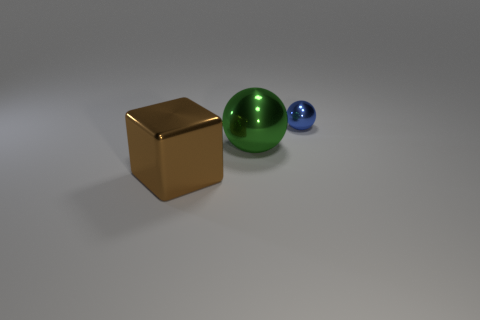Is there anything else that is the same size as the blue sphere?
Your response must be concise. No. There is a object that is behind the large green sphere; is it the same size as the sphere that is left of the small ball?
Your answer should be very brief. No. What number of other objects are there of the same material as the big brown thing?
Your answer should be very brief. 2. Is the number of green objects right of the small object greater than the number of brown shiny objects that are on the left side of the brown metal object?
Ensure brevity in your answer.  No. There is a large object on the right side of the large metal cube; what is its material?
Keep it short and to the point. Metal. Is the blue metallic thing the same shape as the green object?
Offer a terse response. Yes. Is there anything else of the same color as the metallic cube?
Give a very brief answer. No. What is the color of the tiny thing that is the same shape as the big green object?
Keep it short and to the point. Blue. Are there more green balls that are in front of the green thing than large metallic blocks?
Ensure brevity in your answer.  No. What is the color of the large object right of the large brown block?
Keep it short and to the point. Green. 